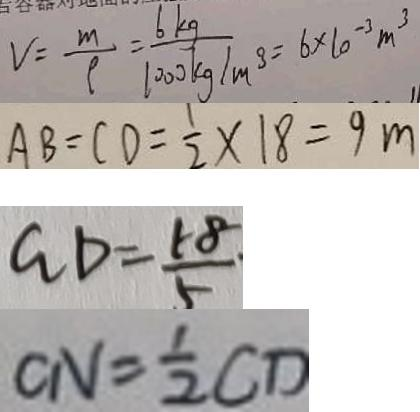Convert formula to latex. <formula><loc_0><loc_0><loc_500><loc_500>V = \frac { m } { \rho } = \frac { 6 k g } { 1 0 0 0 k g / m ^ { 3 } } = 6 \times 1 0 ^ { - 3 } m ^ { 3 } 
 A B = C D = \frac { 1 } { 2 } \times 1 8 = 9 m 
 G D = \frac { 1 8 } { 5 } 
 C N = \frac { 1 } { 2 } C D</formula> 